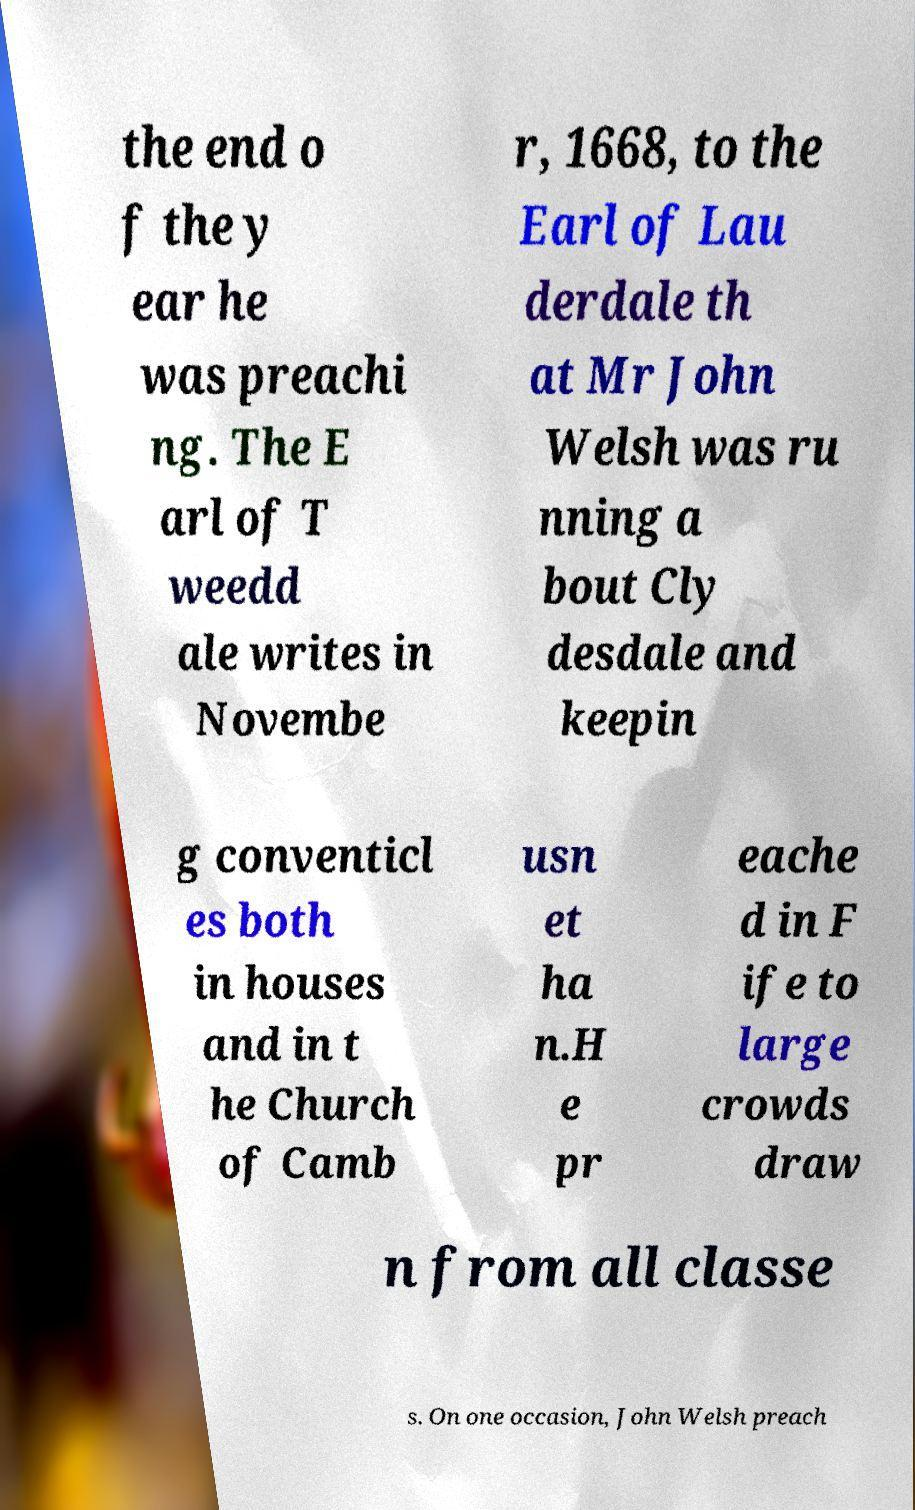Could you assist in decoding the text presented in this image and type it out clearly? the end o f the y ear he was preachi ng. The E arl of T weedd ale writes in Novembe r, 1668, to the Earl of Lau derdale th at Mr John Welsh was ru nning a bout Cly desdale and keepin g conventicl es both in houses and in t he Church of Camb usn et ha n.H e pr eache d in F ife to large crowds draw n from all classe s. On one occasion, John Welsh preach 